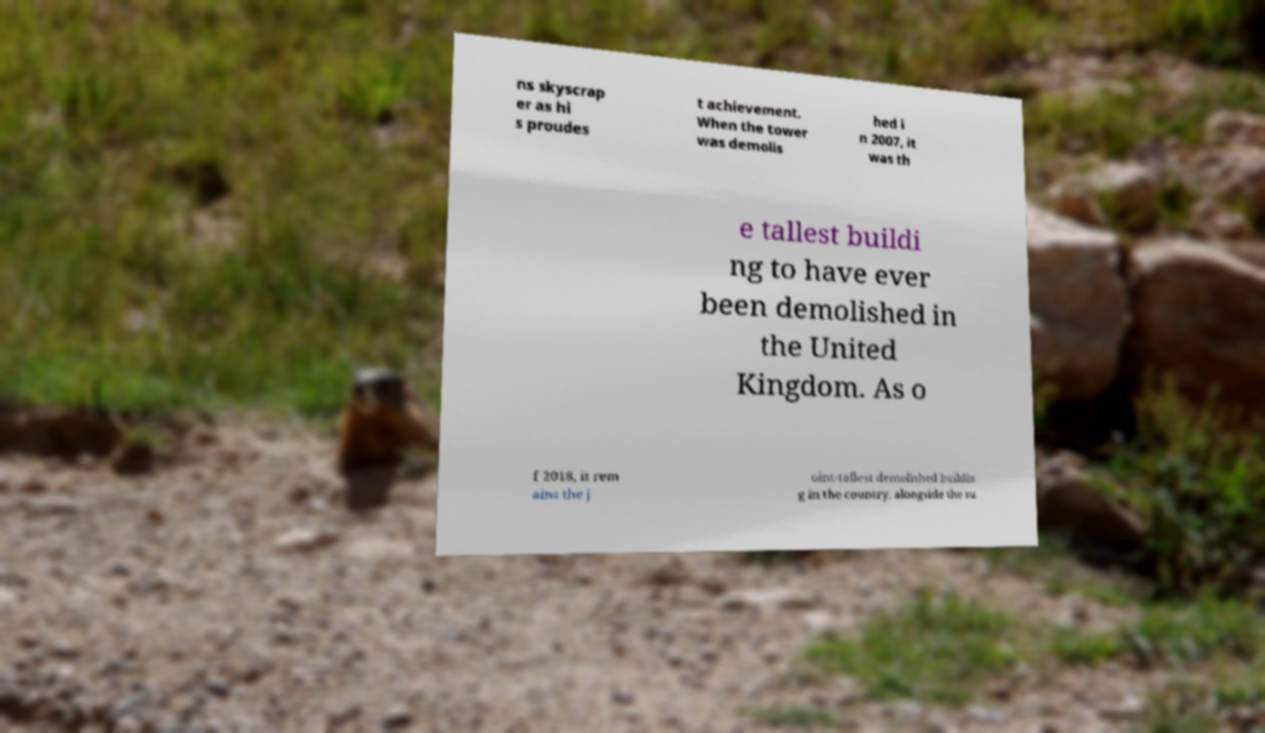Could you assist in decoding the text presented in this image and type it out clearly? ns skyscrap er as hi s proudes t achievement. When the tower was demolis hed i n 2007, it was th e tallest buildi ng to have ever been demolished in the United Kingdom. As o f 2018, it rem ains the j oint-tallest demolished buildin g in the country, alongside the su 